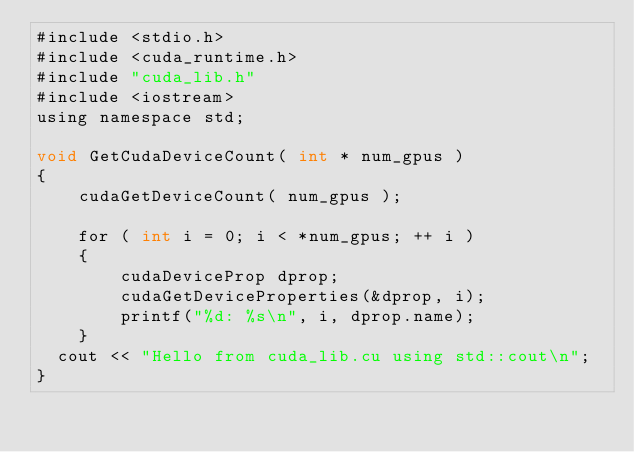Convert code to text. <code><loc_0><loc_0><loc_500><loc_500><_Cuda_>#include <stdio.h>
#include <cuda_runtime.h>
#include "cuda_lib.h"
#include <iostream>
using namespace std;

void GetCudaDeviceCount( int * num_gpus )
{
    cudaGetDeviceCount( num_gpus );

    for ( int i = 0; i < *num_gpus; ++ i )
    {
        cudaDeviceProp dprop;
        cudaGetDeviceProperties(&dprop, i);
        printf("%d: %s\n", i, dprop.name);
    }
	cout << "Hello from cuda_lib.cu using std::cout\n";
}

</code> 